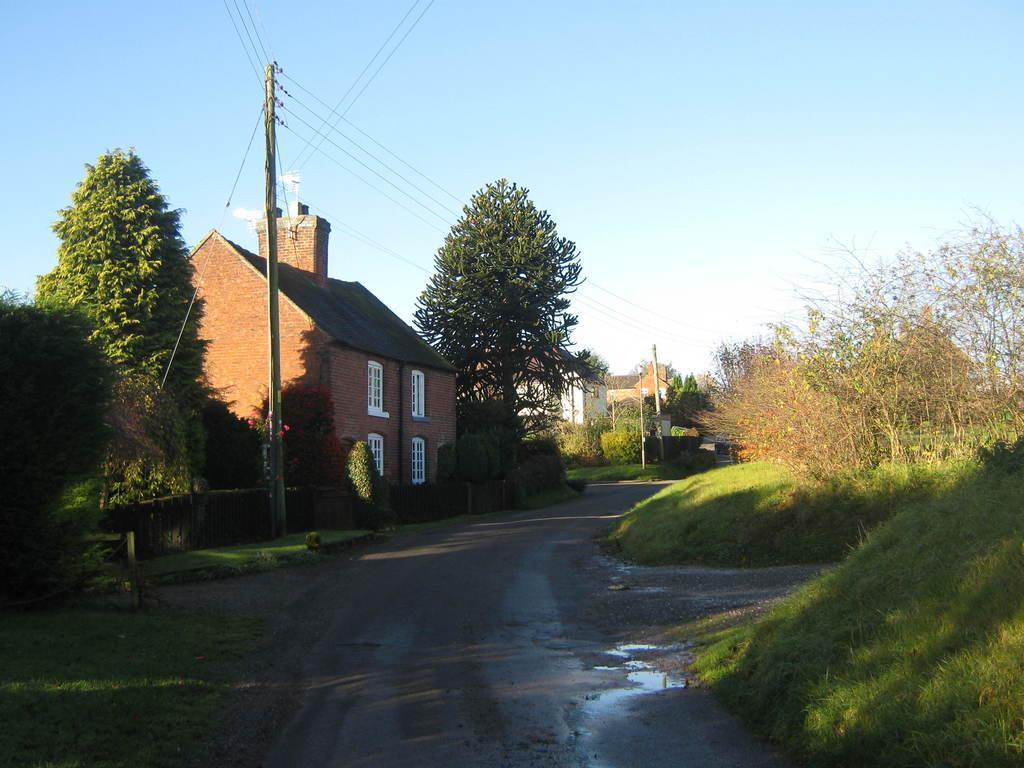What type of structures can be seen in the image? There are houses in the image. What type of vegetation is present in the image? There are trees, shrubs, and grass in the image. What part of the natural environment is visible in the image? The sky is visible in the image. What man-made structures are present in the image? There are electrical poles with wires in the image. What type of surface can be seen in the image? There is a road in the image. What natural element is visible in the image? There is water visible in the image. What type of alarm can be heard going off in the image? There is no alarm present in the image, and therefore no sound can be heard. Can you describe the father in the image? There is no father present in the image. What type of fan is visible in the image? There is no fan present in the image. 